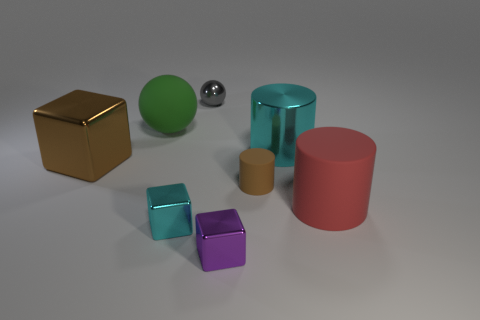Subtract 1 cylinders. How many cylinders are left? 2 Add 1 rubber objects. How many objects exist? 9 Subtract all spheres. How many objects are left? 6 Add 2 large purple shiny cylinders. How many large purple shiny cylinders exist? 2 Subtract 0 green blocks. How many objects are left? 8 Subtract all red balls. Subtract all cyan blocks. How many objects are left? 7 Add 6 cyan cubes. How many cyan cubes are left? 7 